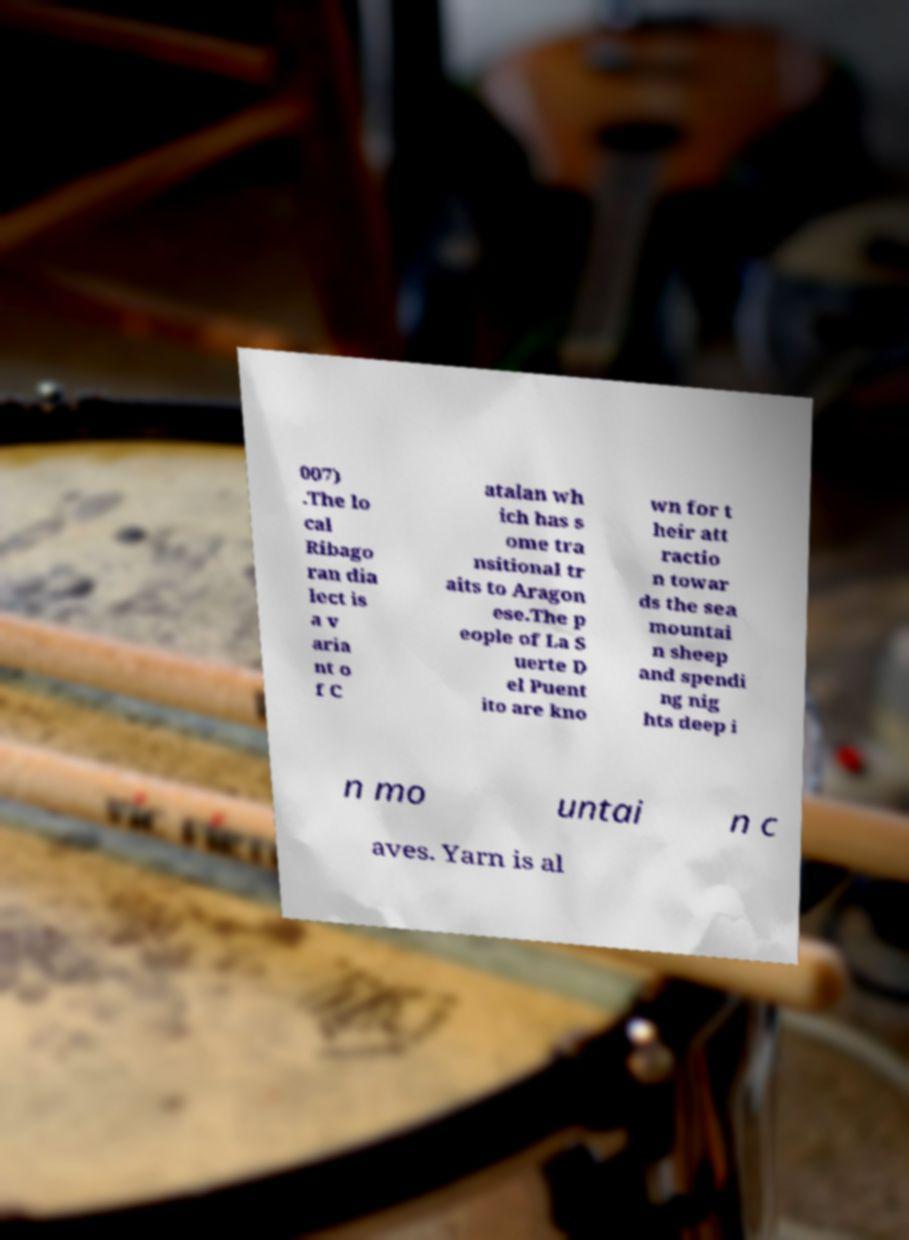What messages or text are displayed in this image? I need them in a readable, typed format. 007) .The lo cal Ribago ran dia lect is a v aria nt o f C atalan wh ich has s ome tra nsitional tr aits to Aragon ese.The p eople of La S uerte D el Puent ito are kno wn for t heir att ractio n towar ds the sea mountai n sheep and spendi ng nig hts deep i n mo untai n c aves. Yarn is al 